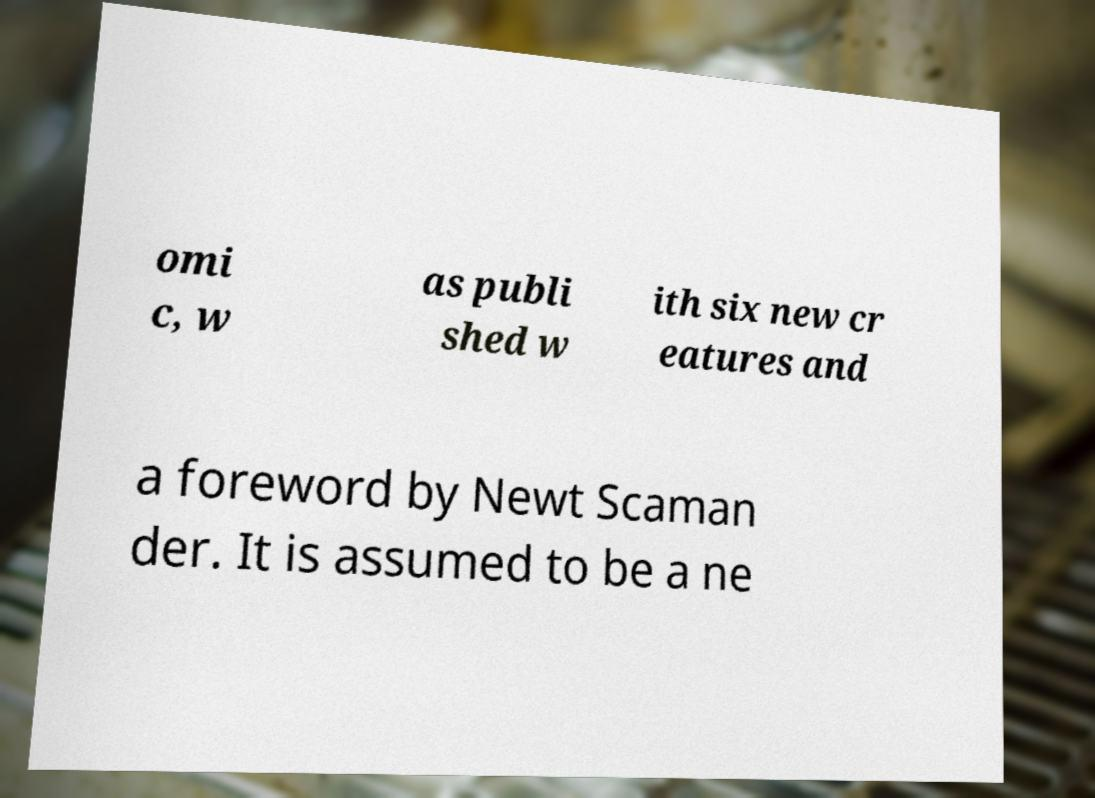Can you read and provide the text displayed in the image?This photo seems to have some interesting text. Can you extract and type it out for me? omi c, w as publi shed w ith six new cr eatures and a foreword by Newt Scaman der. It is assumed to be a ne 